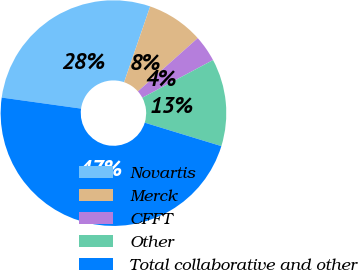Convert chart to OTSL. <chart><loc_0><loc_0><loc_500><loc_500><pie_chart><fcel>Novartis<fcel>Merck<fcel>CFFT<fcel>Other<fcel>Total collaborative and other<nl><fcel>28.08%<fcel>8.15%<fcel>3.78%<fcel>12.52%<fcel>47.48%<nl></chart> 